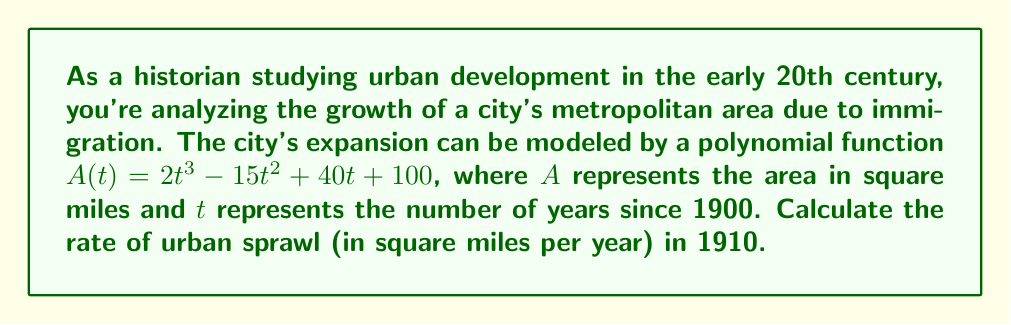Provide a solution to this math problem. To solve this problem, we need to follow these steps:

1) The rate of urban sprawl is represented by the rate of change of the area with respect to time. This is given by the first derivative of the area function $A(t)$.

2) Let's find the derivative of $A(t)$:
   $$A(t) = 2t^3 - 15t^2 + 40t + 100$$
   $$A'(t) = 6t^2 - 30t + 40$$

3) The derivative $A'(t)$ represents the rate of change of area at any given time $t$.

4) We need to find the rate in 1910, which is 10 years after 1900. So we need to calculate $A'(10)$.

5) Let's substitute $t = 10$ into our derivative function:
   $$A'(10) = 6(10)^2 - 30(10) + 40$$
   $$= 6(100) - 300 + 40$$
   $$= 600 - 300 + 40$$
   $$= 340$$

Therefore, the rate of urban sprawl in 1910 was 340 square miles per year.
Answer: 340 square miles per year 